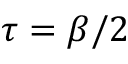Convert formula to latex. <formula><loc_0><loc_0><loc_500><loc_500>\tau = \beta / 2</formula> 